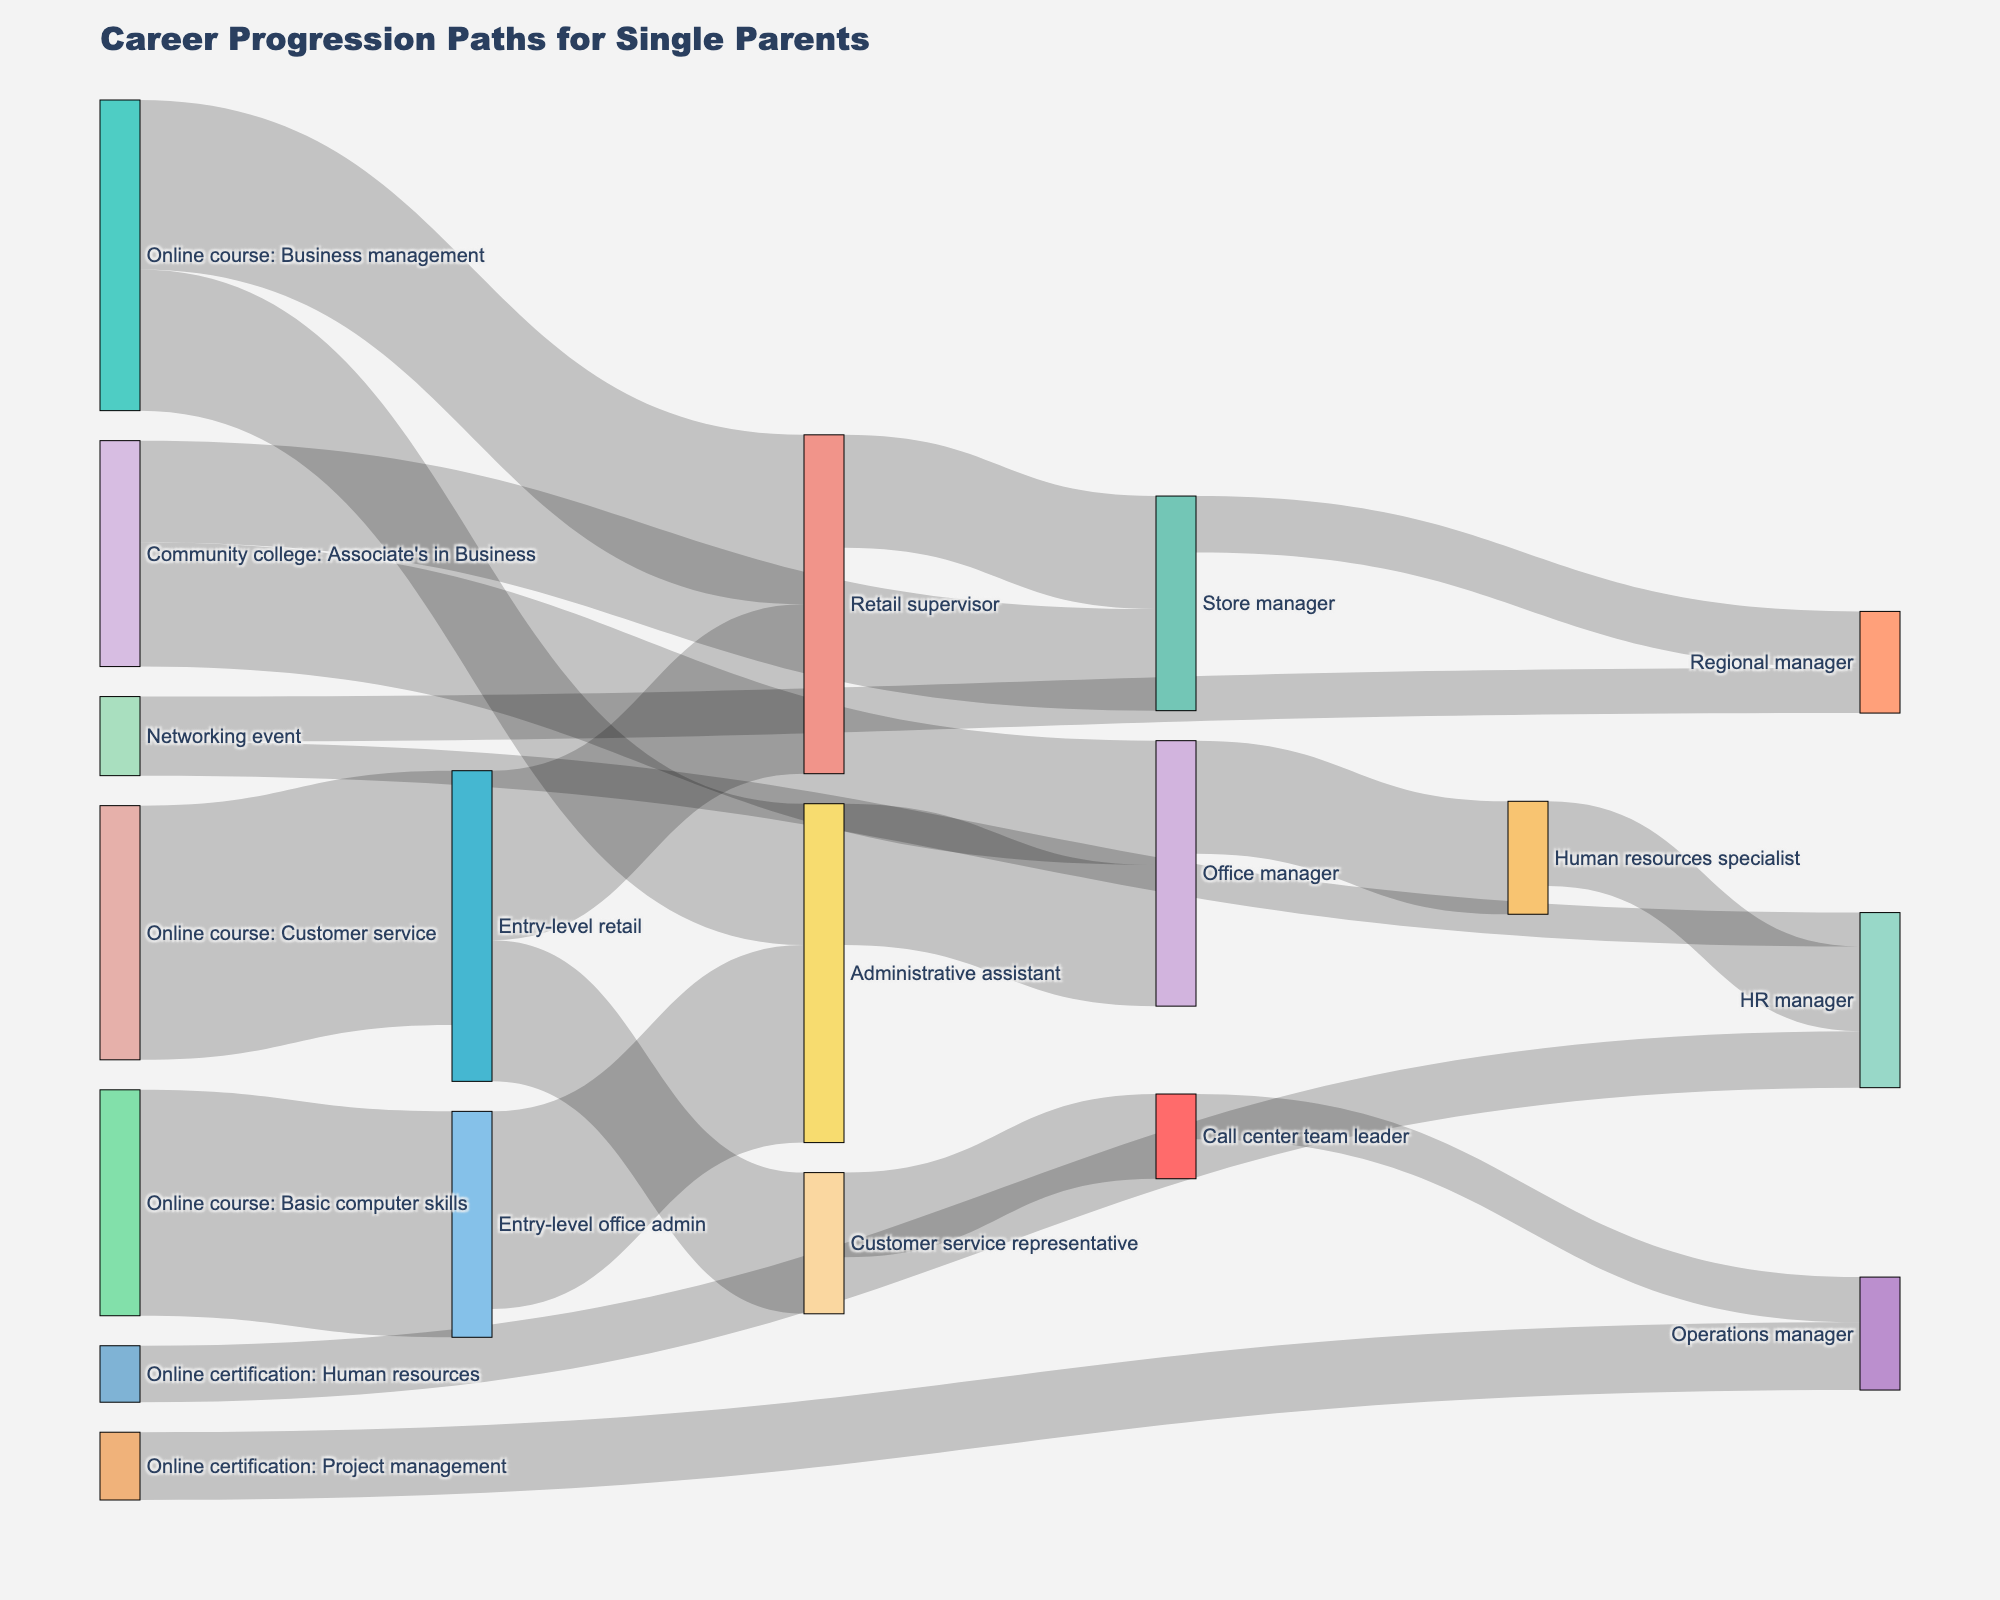how many unique career paths are depicted in the figure? to determine the number of unique career paths, count the unique combinations of source and target labels in the figure. each combination represents a different career path.
Answer: 15 which job transition has the highest value? find the source and target pair with the largest value. in this case, the transition from "online course: customer service" to "entry-level retail" has the highest value of 45.
Answer: "Online course: Customer service" to "Entry-level retail" with a value of 45 what is the value difference between the career transitions from "entry-level retail" to "retail supervisor" and from "entry-level retail" to "customer service representative"? subtract the value of the second transition (25) from the first (30). 30 - 25 = 5.
Answer: 5 which job transition after "store manager" leads to a higher position, and what is that position? only one job transition from "store manager" to "regional manager" exists. the "regional manager" position is the higher position.
Answer: "Regional Manager" how many career paths begin with an online course? by identifying the nodes starting with "online course", which are three: basic computer skills, customer service, and business management. check the associated target nodes for each source. there are four such paths.
Answer: 4 do more people transition from "administrative assistant" to "office manager" or "office manager" to "human resources specialist"? compare the values of each transition. the value for "administrative assistant" to "office manager" is 25. the value for "office manager" to "human resources specialist" is 20.
Answer: "Administrative Assistant" to "Office Manager" what is the sum of values for all sole transitions originating from "online course: business management"? add the values for the target nodes from "online course: business management": retail supervisor (30) and administrative assistant (25). 30 + 25 = 55.
Answer: 55 how many job transitions eventually lead to an HR-related role? identify pathways ending at "HR manager" and sum up the values for transitions leading to it. involve paths from "human resources specialist" and transitions signifying upward mobility.
Answer: 2 which job position has the most different transition options leading from it? evaluate the target nodes for each job position and count how many different transition pathways exist from each. "entry-level retail" has the most with two different paths.
Answer: "Entry-level retail" are there job transitions facilitated by attending networking events, and if so, how many people take this route? identify transitions tagged with "networking event" as the source node. two pathways are shown with values summing up to 14 (regional manager 8 + hr manager 6).
Answer: 14 